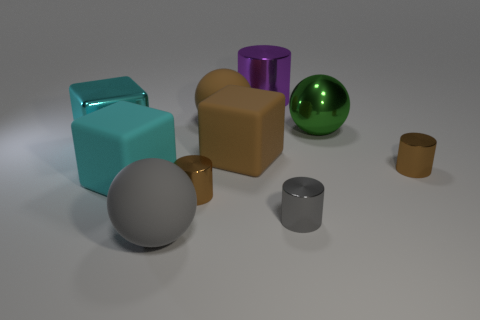Subtract all cylinders. How many objects are left? 6 Add 8 gray metal things. How many gray metal things are left? 9 Add 5 large gray objects. How many large gray objects exist? 6 Subtract 0 gray cubes. How many objects are left? 10 Subtract all large brown rubber spheres. Subtract all tiny cylinders. How many objects are left? 6 